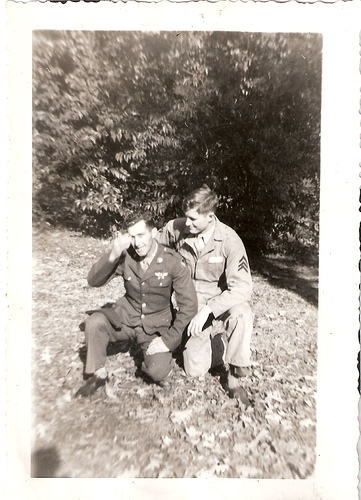<image>
Is the soldier on the leaves? No. The soldier is not positioned on the leaves. They may be near each other, but the soldier is not supported by or resting on top of the leaves. Where is the dude in relation to the man? Is it behind the man? No. The dude is not behind the man. From this viewpoint, the dude appears to be positioned elsewhere in the scene. Is there a serviceman behind the other serviceman? No. The serviceman is not behind the other serviceman. From this viewpoint, the serviceman appears to be positioned elsewhere in the scene. 